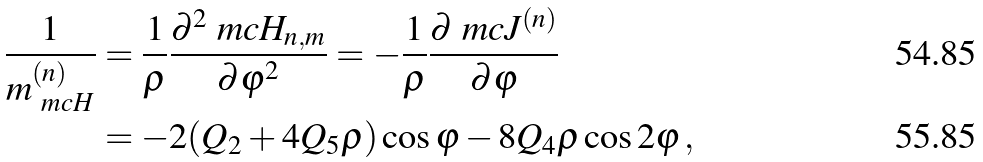<formula> <loc_0><loc_0><loc_500><loc_500>\frac { 1 } { m _ { \ m c { H } } ^ { ( n ) } } & = \frac { 1 } { \rho } \frac { \partial ^ { 2 } \ m c { H } _ { n , m } } { \partial \varphi ^ { 2 } } = - \frac { 1 } { \rho } \frac { \partial \ m c { J } ^ { ( n ) } } { \partial \varphi } \\ & = - 2 ( Q _ { 2 } + 4 Q _ { 5 } \rho ) \cos \varphi - 8 Q _ { 4 } \rho \cos 2 \varphi \, ,</formula> 